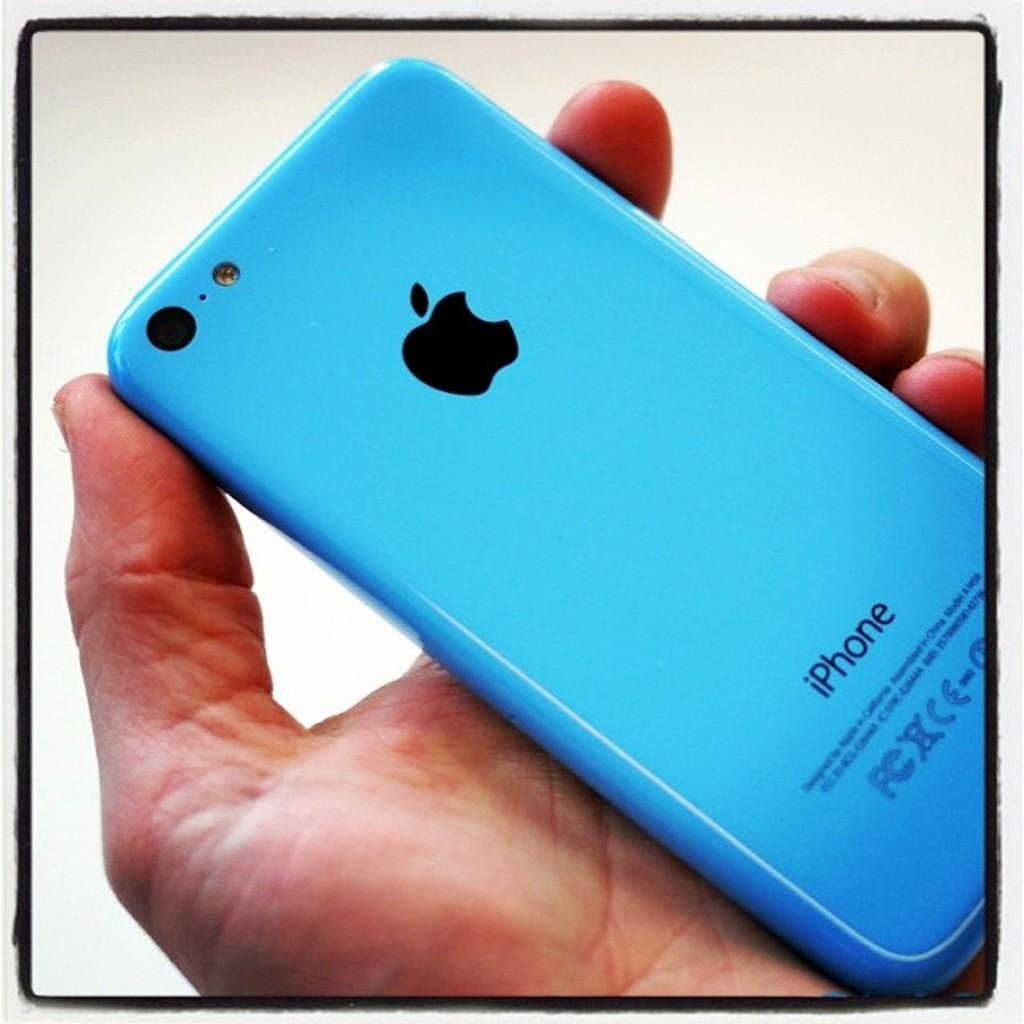<image>
Present a compact description of the photo's key features. Man holding an Apple iPhone in a blue case. 